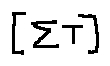Convert formula to latex. <formula><loc_0><loc_0><loc_500><loc_500>[ \sum T ]</formula> 